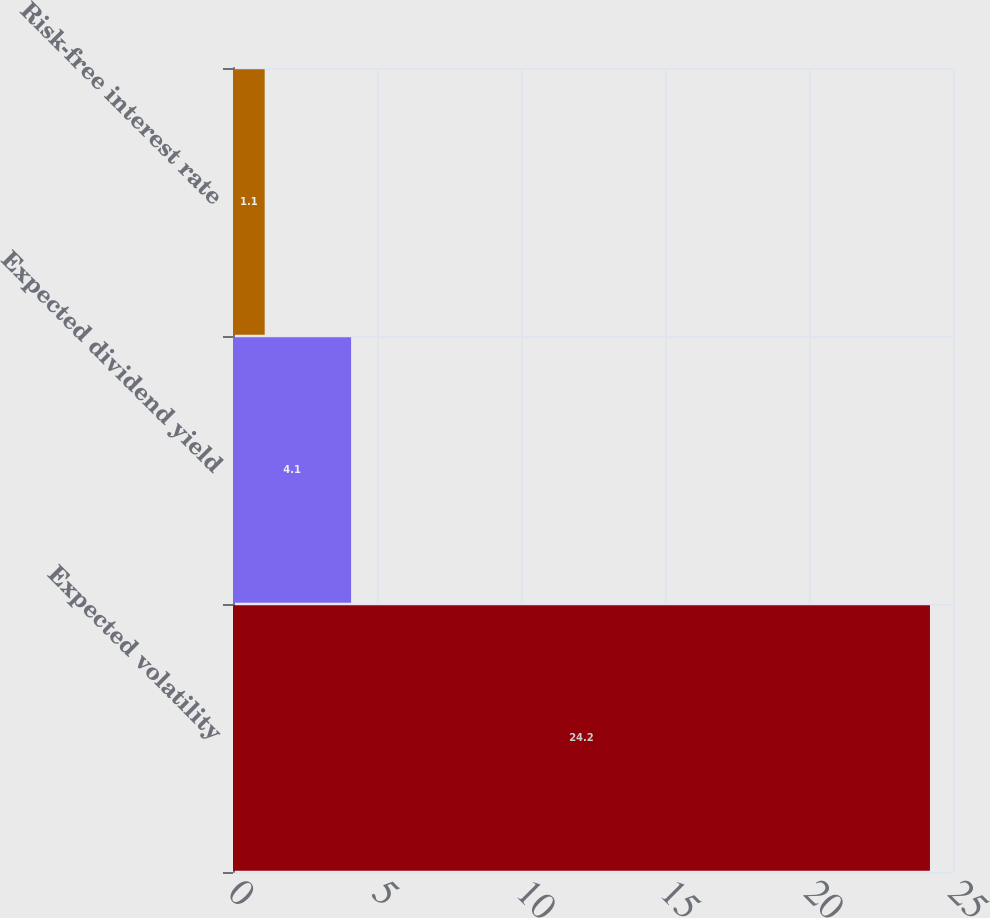<chart> <loc_0><loc_0><loc_500><loc_500><bar_chart><fcel>Expected volatility<fcel>Expected dividend yield<fcel>Risk-free interest rate<nl><fcel>24.2<fcel>4.1<fcel>1.1<nl></chart> 